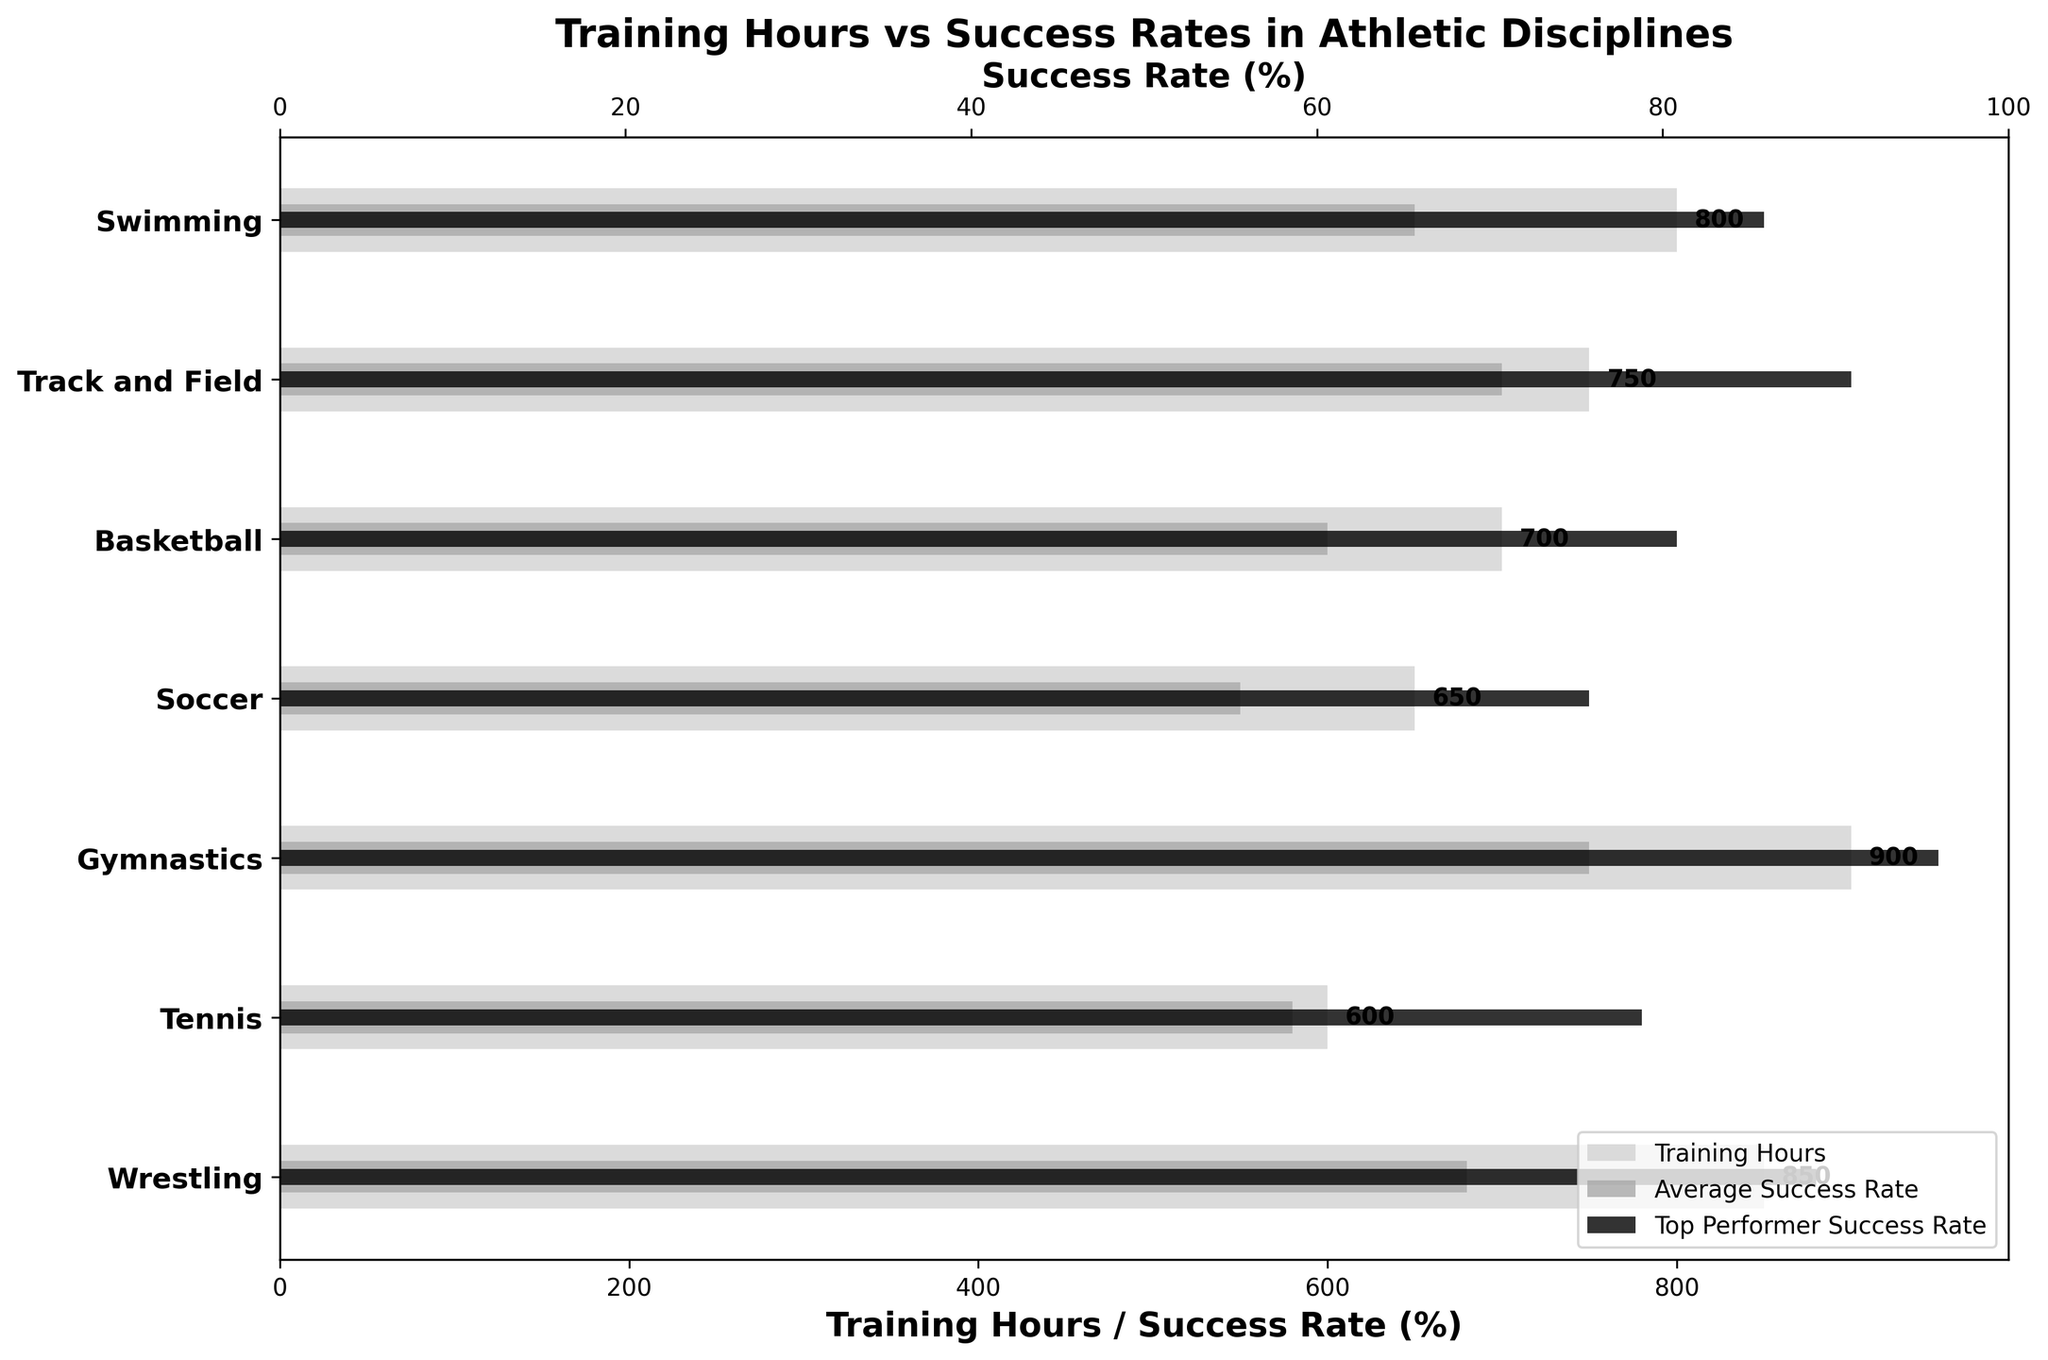What is the title of the figure? The title is located at the top of the figure.
Answer: Training Hours vs Success Rates in Athletic Disciplines Which sports have the highest and lowest training hours? Look at the longest and shortest bars corresponding to training hours.
Answer: Gymnastics, Tennis How many sports are compared in the figure? Count the number of labels on the y-axis.
Answer: 7 What is the success rate of the top performer in Gymnastics? Identify the value of the black bar corresponding to Gymnastics on the figure.
Answer: 95% Which sport has a higher average success rate, Soccer or Wrestling? Compare the length of the dark gray bars for Soccer and Wrestling.
Answer: Wrestling What is the difference in training hours between Swimming and Soccer? Subtract the training hours of Soccer from Swimming: 800 - 650.
Answer: 150 hours How does the average success rate in Basketball compare to its top performer's success rate? Examine the lengths of the dark gray and black bars for Basketball and note the difference.
Answer: 20% lower Which sports show an average success rate higher than 60%? Identify the dark gray bars longer than the line corresponding to 60.
Answer: Track and Field, Swimming, Wrestling, Gymnastics What is the total training hours for all the sports combined? Sum the training hours of all sports: 800 + 750 + 700 + 650 + 900 + 600 + 850.
Answer: 5250 hours Which sport has the smallest gap between average and top performer success rates, and what is the size of the gap? Subtract the average success rate from the top performer success rate for each sport, and find the smallest result.
Answer: Swimming, 20% 